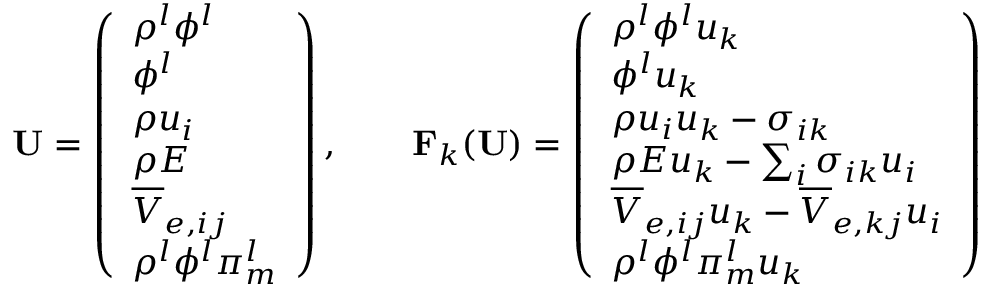<formula> <loc_0><loc_0><loc_500><loc_500>U = \left ( \begin{array} { l } { \rho ^ { l } \phi ^ { l } } \\ { \phi ^ { l } } \\ { \rho u _ { i } } \\ { \rho E } \\ { \overline { V } _ { e , i j } } \\ { \rho ^ { l } \phi ^ { l } \pi _ { m } ^ { l } } \end{array} \right ) , \quad F _ { k } ( U ) = \left ( \begin{array} { l } { \rho ^ { l } \phi ^ { l } u _ { k } } \\ { \phi ^ { l } u _ { k } } \\ { \rho u _ { i } u _ { k } - \sigma _ { i k } } \\ { \rho E u _ { k } - \sum _ { i } \sigma _ { i k } u _ { i } } \\ { \overline { V } _ { e , i j } u _ { k } - \overline { V } _ { e , k j } u _ { i } } \\ { \rho ^ { l } \phi ^ { l } \pi _ { m } ^ { l } u _ { k } } \end{array} \right )</formula> 